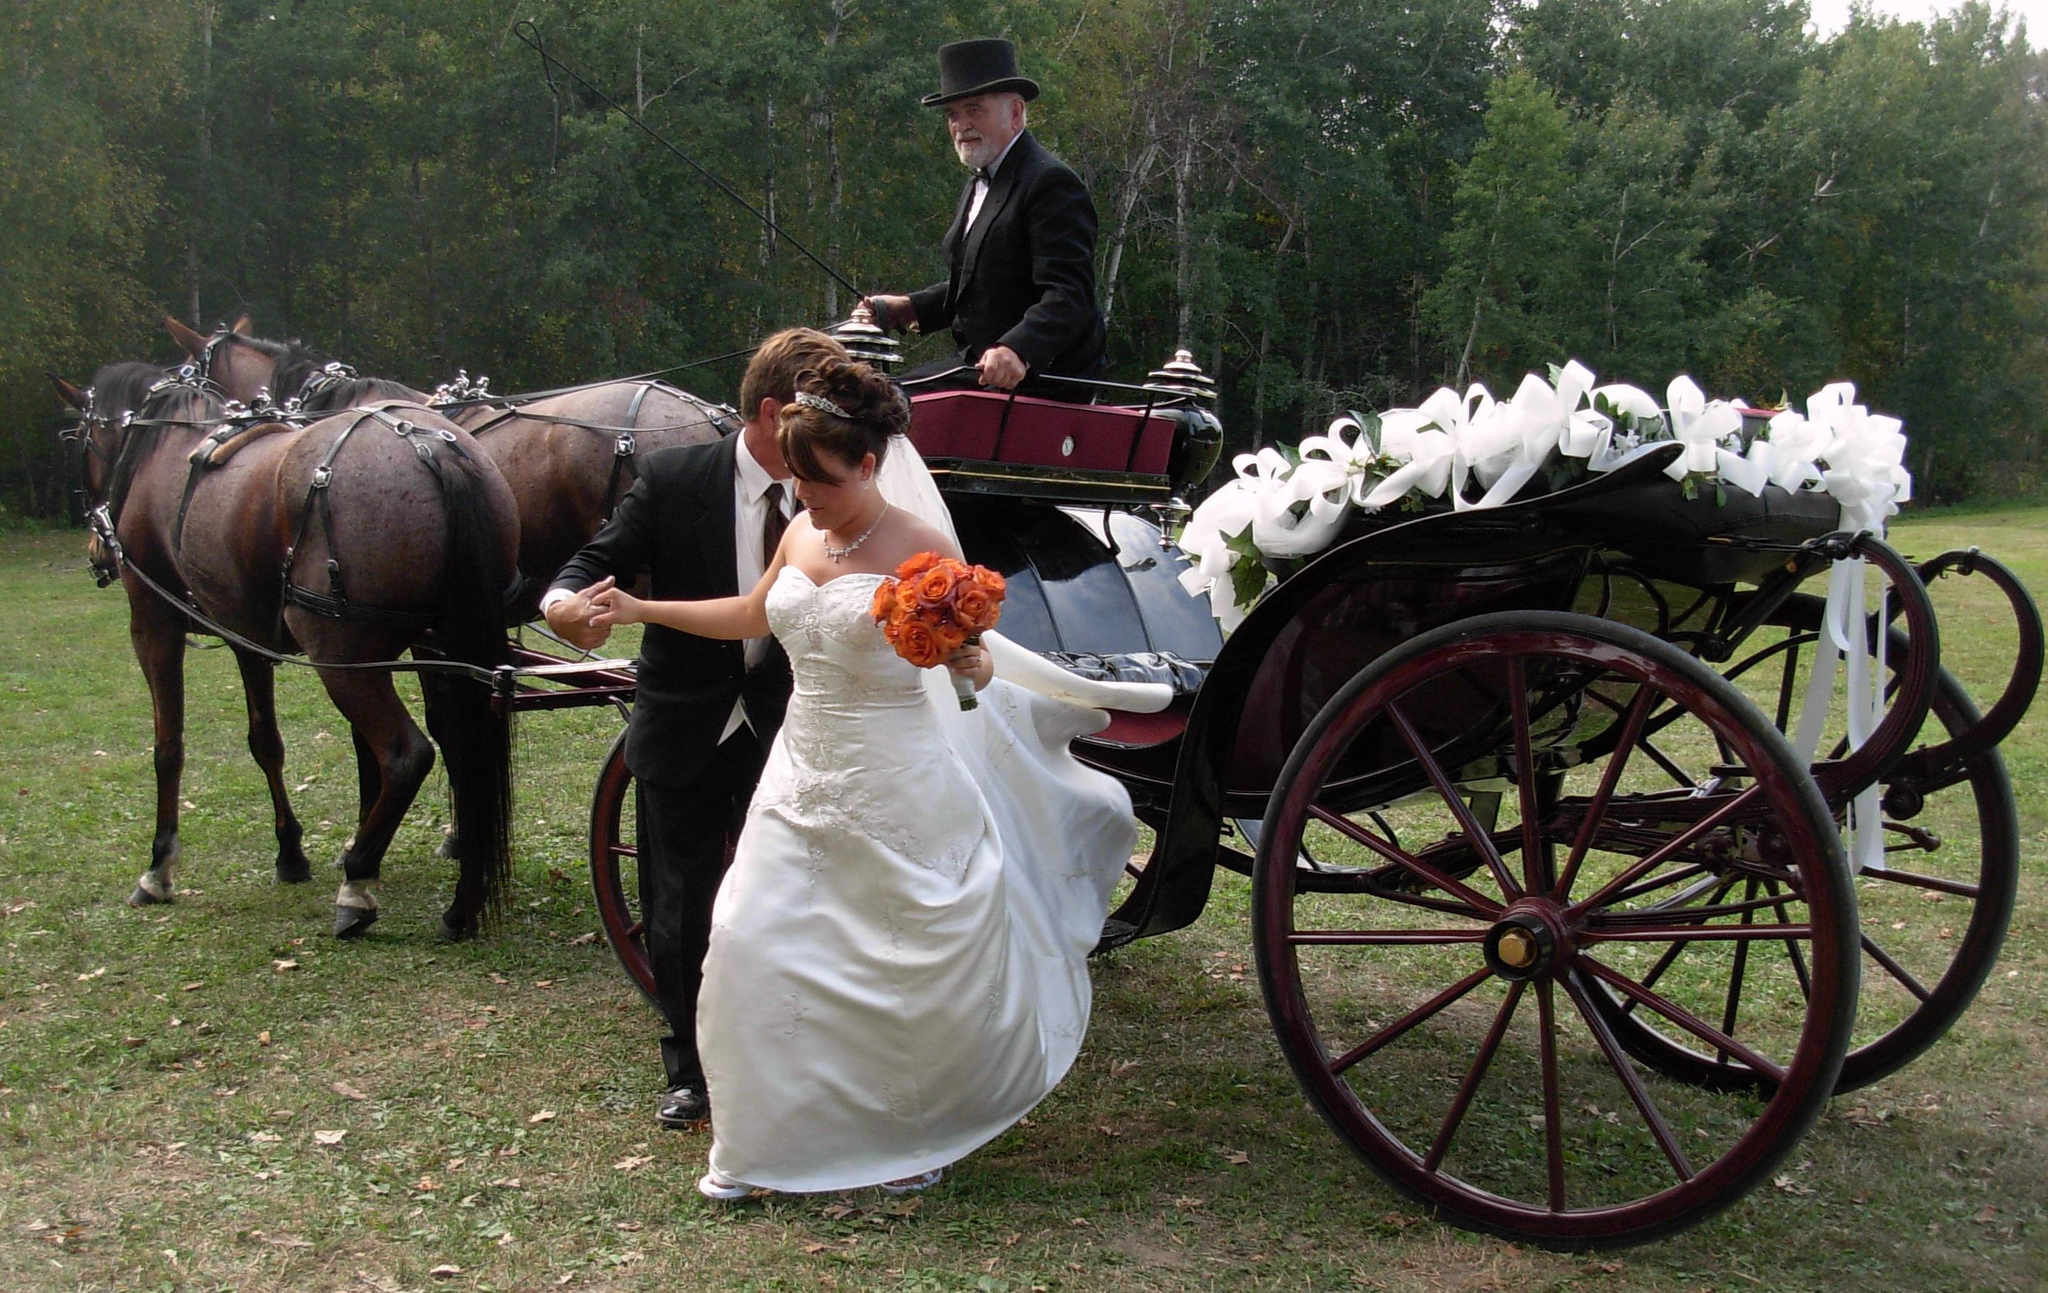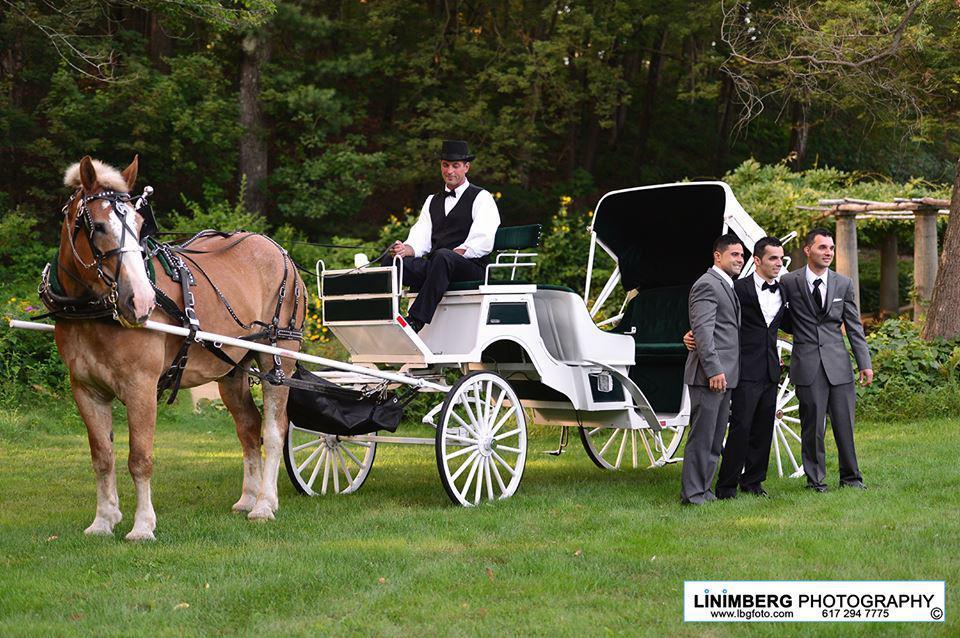The first image is the image on the left, the second image is the image on the right. Evaluate the accuracy of this statement regarding the images: "In both images, a bride is visible next to a horse and carriage.". Is it true? Answer yes or no. No. 